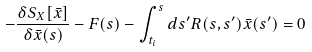Convert formula to latex. <formula><loc_0><loc_0><loc_500><loc_500>- \frac { \delta S _ { X } [ \bar { x } ] } { \delta \bar { x } ( s ) } - F ( s ) - \int _ { t _ { i } } ^ { s } d s ^ { \prime } R ( s , s ^ { \prime } ) \bar { x } ( s ^ { \prime } ) = 0</formula> 